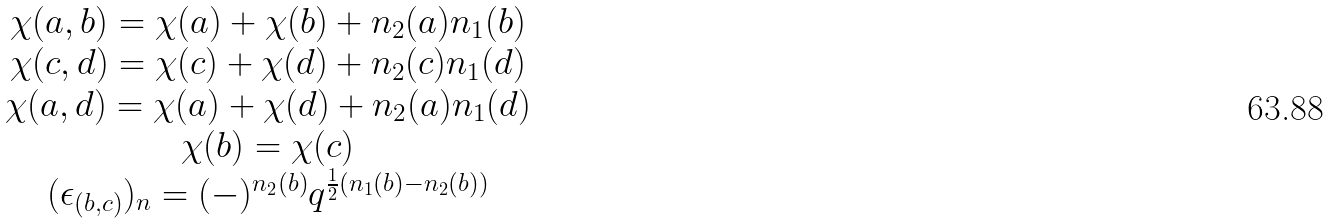<formula> <loc_0><loc_0><loc_500><loc_500>\begin{array} { c } \chi ( a , b ) = \chi ( a ) + \chi ( b ) + n _ { 2 } ( a ) n _ { 1 } ( b ) \\ \chi ( c , d ) = \chi ( c ) + \chi ( d ) + n _ { 2 } ( c ) n _ { 1 } ( d ) \\ \chi ( a , d ) = \chi ( a ) + \chi ( d ) + n _ { 2 } ( a ) n _ { 1 } ( d ) \\ \chi ( b ) = \chi ( c ) \\ ( \epsilon _ { ( b , c ) } ) _ { n } = ( - ) ^ { n _ { 2 } ( b ) } q ^ { \frac { 1 } { 2 } ( n _ { 1 } ( b ) - n _ { 2 } ( b ) ) } \end{array}</formula> 